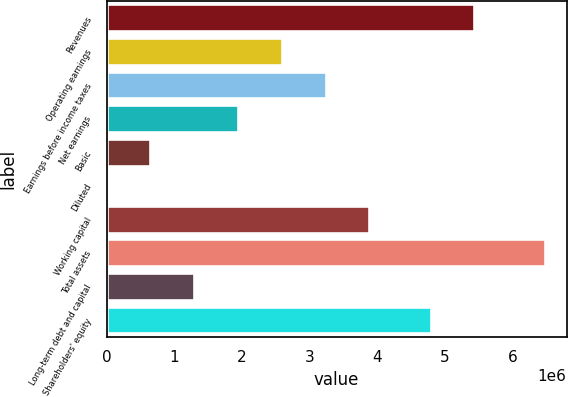Convert chart. <chart><loc_0><loc_0><loc_500><loc_500><bar_chart><fcel>Revenues<fcel>Operating earnings<fcel>Earnings before income taxes<fcel>Net earnings<fcel>Basic<fcel>Diluted<fcel>Working capital<fcel>Total assets<fcel>Long-term debt and capital<fcel>Shareholders' equity<nl><fcel>5.43228e+06<fcel>2.58773e+06<fcel>3.23466e+06<fcel>1.9408e+06<fcel>646933<fcel>2.57<fcel>3.88159e+06<fcel>6.46931e+06<fcel>1.29386e+06<fcel>4.78535e+06<nl></chart> 